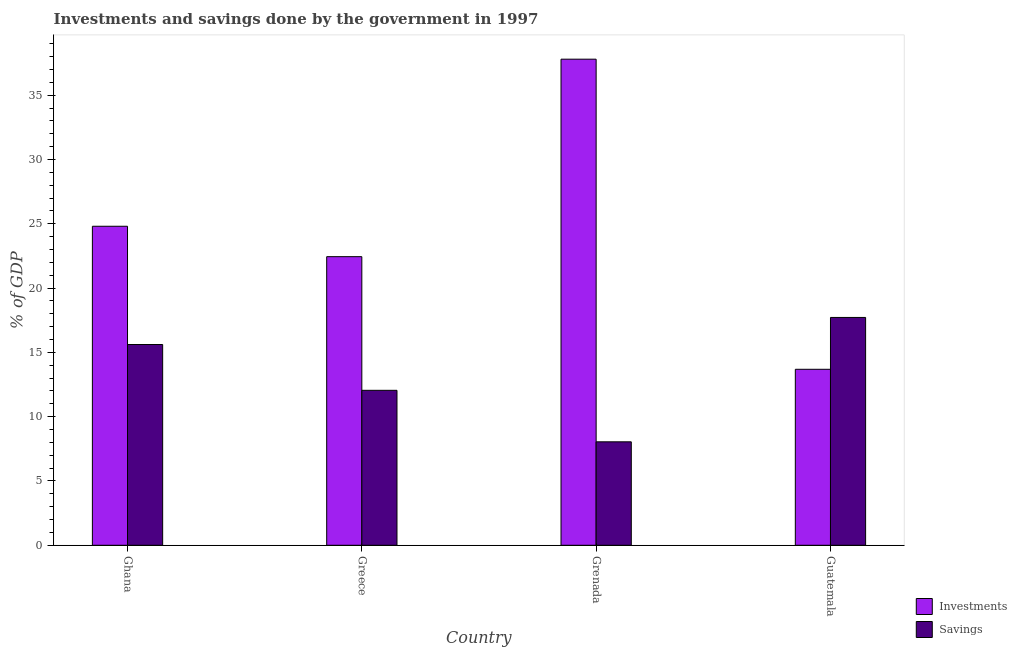How many groups of bars are there?
Your answer should be very brief. 4. Are the number of bars per tick equal to the number of legend labels?
Ensure brevity in your answer.  Yes. Are the number of bars on each tick of the X-axis equal?
Give a very brief answer. Yes. How many bars are there on the 2nd tick from the left?
Give a very brief answer. 2. How many bars are there on the 1st tick from the right?
Your answer should be very brief. 2. What is the label of the 3rd group of bars from the left?
Keep it short and to the point. Grenada. What is the investments of government in Guatemala?
Make the answer very short. 13.68. Across all countries, what is the maximum investments of government?
Offer a terse response. 37.8. Across all countries, what is the minimum savings of government?
Ensure brevity in your answer.  8.04. In which country was the savings of government maximum?
Make the answer very short. Guatemala. In which country was the investments of government minimum?
Provide a short and direct response. Guatemala. What is the total savings of government in the graph?
Your answer should be very brief. 53.42. What is the difference between the savings of government in Greece and that in Guatemala?
Ensure brevity in your answer.  -5.67. What is the difference between the investments of government in Ghana and the savings of government in Greece?
Keep it short and to the point. 12.76. What is the average savings of government per country?
Offer a terse response. 13.36. What is the difference between the savings of government and investments of government in Greece?
Offer a very short reply. -10.39. In how many countries, is the investments of government greater than 16 %?
Your answer should be compact. 3. What is the ratio of the savings of government in Ghana to that in Greece?
Your response must be concise. 1.3. Is the investments of government in Ghana less than that in Grenada?
Keep it short and to the point. Yes. What is the difference between the highest and the second highest savings of government?
Your answer should be compact. 2.1. What is the difference between the highest and the lowest savings of government?
Make the answer very short. 9.67. Is the sum of the savings of government in Greece and Grenada greater than the maximum investments of government across all countries?
Provide a short and direct response. No. What does the 2nd bar from the left in Ghana represents?
Offer a very short reply. Savings. What does the 1st bar from the right in Greece represents?
Your answer should be compact. Savings. How many bars are there?
Your response must be concise. 8. Are all the bars in the graph horizontal?
Provide a short and direct response. No. What is the difference between two consecutive major ticks on the Y-axis?
Make the answer very short. 5. Does the graph contain any zero values?
Provide a short and direct response. No. Does the graph contain grids?
Offer a very short reply. No. How many legend labels are there?
Your answer should be very brief. 2. What is the title of the graph?
Offer a terse response. Investments and savings done by the government in 1997. What is the label or title of the X-axis?
Give a very brief answer. Country. What is the label or title of the Y-axis?
Make the answer very short. % of GDP. What is the % of GDP of Investments in Ghana?
Make the answer very short. 24.81. What is the % of GDP of Savings in Ghana?
Your answer should be compact. 15.61. What is the % of GDP of Investments in Greece?
Provide a succinct answer. 22.44. What is the % of GDP in Savings in Greece?
Give a very brief answer. 12.05. What is the % of GDP in Investments in Grenada?
Your answer should be compact. 37.8. What is the % of GDP in Savings in Grenada?
Your response must be concise. 8.04. What is the % of GDP of Investments in Guatemala?
Your answer should be compact. 13.68. What is the % of GDP of Savings in Guatemala?
Your answer should be very brief. 17.72. Across all countries, what is the maximum % of GDP in Investments?
Your answer should be very brief. 37.8. Across all countries, what is the maximum % of GDP of Savings?
Your response must be concise. 17.72. Across all countries, what is the minimum % of GDP in Investments?
Keep it short and to the point. 13.68. Across all countries, what is the minimum % of GDP of Savings?
Your answer should be very brief. 8.04. What is the total % of GDP in Investments in the graph?
Provide a short and direct response. 98.73. What is the total % of GDP of Savings in the graph?
Keep it short and to the point. 53.42. What is the difference between the % of GDP of Investments in Ghana and that in Greece?
Your answer should be very brief. 2.37. What is the difference between the % of GDP of Savings in Ghana and that in Greece?
Your answer should be compact. 3.56. What is the difference between the % of GDP in Investments in Ghana and that in Grenada?
Make the answer very short. -12.99. What is the difference between the % of GDP in Savings in Ghana and that in Grenada?
Your response must be concise. 7.57. What is the difference between the % of GDP of Investments in Ghana and that in Guatemala?
Offer a very short reply. 11.12. What is the difference between the % of GDP of Savings in Ghana and that in Guatemala?
Offer a terse response. -2.1. What is the difference between the % of GDP of Investments in Greece and that in Grenada?
Keep it short and to the point. -15.36. What is the difference between the % of GDP in Savings in Greece and that in Grenada?
Offer a terse response. 4. What is the difference between the % of GDP in Investments in Greece and that in Guatemala?
Give a very brief answer. 8.76. What is the difference between the % of GDP in Savings in Greece and that in Guatemala?
Your answer should be very brief. -5.67. What is the difference between the % of GDP in Investments in Grenada and that in Guatemala?
Offer a terse response. 24.11. What is the difference between the % of GDP in Savings in Grenada and that in Guatemala?
Provide a succinct answer. -9.67. What is the difference between the % of GDP in Investments in Ghana and the % of GDP in Savings in Greece?
Offer a very short reply. 12.76. What is the difference between the % of GDP in Investments in Ghana and the % of GDP in Savings in Grenada?
Provide a short and direct response. 16.76. What is the difference between the % of GDP of Investments in Ghana and the % of GDP of Savings in Guatemala?
Your response must be concise. 7.09. What is the difference between the % of GDP in Investments in Greece and the % of GDP in Savings in Grenada?
Keep it short and to the point. 14.4. What is the difference between the % of GDP of Investments in Greece and the % of GDP of Savings in Guatemala?
Offer a very short reply. 4.73. What is the difference between the % of GDP in Investments in Grenada and the % of GDP in Savings in Guatemala?
Your answer should be compact. 20.08. What is the average % of GDP in Investments per country?
Provide a short and direct response. 24.68. What is the average % of GDP in Savings per country?
Make the answer very short. 13.36. What is the difference between the % of GDP of Investments and % of GDP of Savings in Ghana?
Provide a short and direct response. 9.2. What is the difference between the % of GDP of Investments and % of GDP of Savings in Greece?
Give a very brief answer. 10.39. What is the difference between the % of GDP in Investments and % of GDP in Savings in Grenada?
Provide a succinct answer. 29.75. What is the difference between the % of GDP in Investments and % of GDP in Savings in Guatemala?
Provide a short and direct response. -4.03. What is the ratio of the % of GDP in Investments in Ghana to that in Greece?
Offer a terse response. 1.11. What is the ratio of the % of GDP in Savings in Ghana to that in Greece?
Give a very brief answer. 1.3. What is the ratio of the % of GDP in Investments in Ghana to that in Grenada?
Offer a terse response. 0.66. What is the ratio of the % of GDP in Savings in Ghana to that in Grenada?
Offer a very short reply. 1.94. What is the ratio of the % of GDP of Investments in Ghana to that in Guatemala?
Your answer should be compact. 1.81. What is the ratio of the % of GDP of Savings in Ghana to that in Guatemala?
Your response must be concise. 0.88. What is the ratio of the % of GDP of Investments in Greece to that in Grenada?
Provide a short and direct response. 0.59. What is the ratio of the % of GDP of Savings in Greece to that in Grenada?
Offer a terse response. 1.5. What is the ratio of the % of GDP in Investments in Greece to that in Guatemala?
Keep it short and to the point. 1.64. What is the ratio of the % of GDP of Savings in Greece to that in Guatemala?
Offer a very short reply. 0.68. What is the ratio of the % of GDP of Investments in Grenada to that in Guatemala?
Your answer should be compact. 2.76. What is the ratio of the % of GDP in Savings in Grenada to that in Guatemala?
Make the answer very short. 0.45. What is the difference between the highest and the second highest % of GDP of Investments?
Ensure brevity in your answer.  12.99. What is the difference between the highest and the second highest % of GDP in Savings?
Provide a short and direct response. 2.1. What is the difference between the highest and the lowest % of GDP of Investments?
Your answer should be very brief. 24.11. What is the difference between the highest and the lowest % of GDP of Savings?
Your response must be concise. 9.67. 